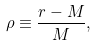Convert formula to latex. <formula><loc_0><loc_0><loc_500><loc_500>\rho \equiv \frac { r - M } { M } ,</formula> 